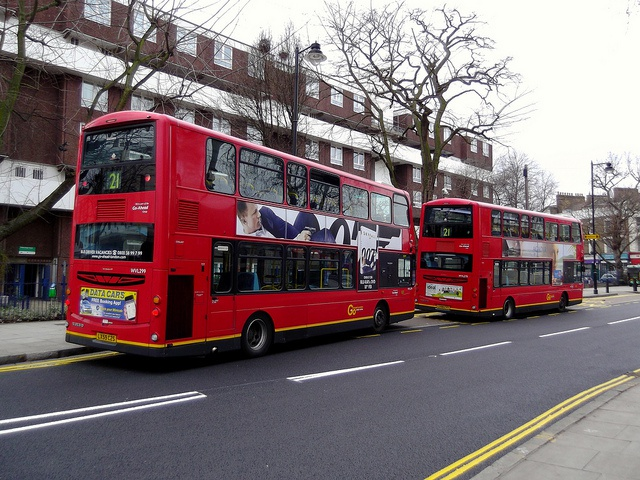Describe the objects in this image and their specific colors. I can see bus in black, brown, gray, and maroon tones and bus in black, brown, gray, and maroon tones in this image. 